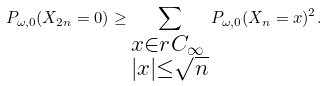Convert formula to latex. <formula><loc_0><loc_0><loc_500><loc_500>P _ { \omega , 0 } ( X _ { 2 n } = 0 ) \geq \sum _ { \begin{subarray} { c } x \in r C _ { \infty } \\ | x | \leq \sqrt { n } \end{subarray} } P _ { \omega , 0 } ( X _ { n } = x ) ^ { 2 } .</formula> 